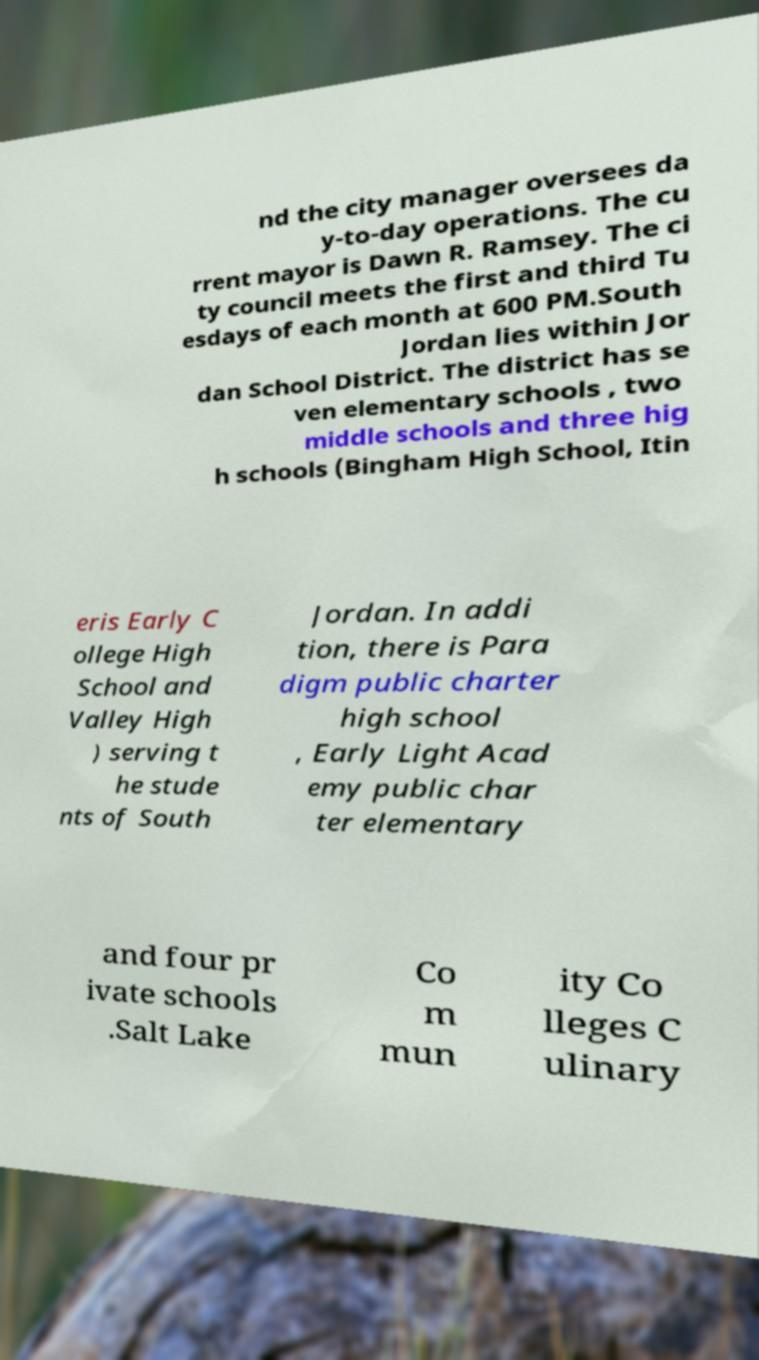For documentation purposes, I need the text within this image transcribed. Could you provide that? nd the city manager oversees da y-to-day operations. The cu rrent mayor is Dawn R. Ramsey. The ci ty council meets the first and third Tu esdays of each month at 600 PM.South Jordan lies within Jor dan School District. The district has se ven elementary schools , two middle schools and three hig h schools (Bingham High School, Itin eris Early C ollege High School and Valley High ) serving t he stude nts of South Jordan. In addi tion, there is Para digm public charter high school , Early Light Acad emy public char ter elementary and four pr ivate schools .Salt Lake Co m mun ity Co lleges C ulinary 